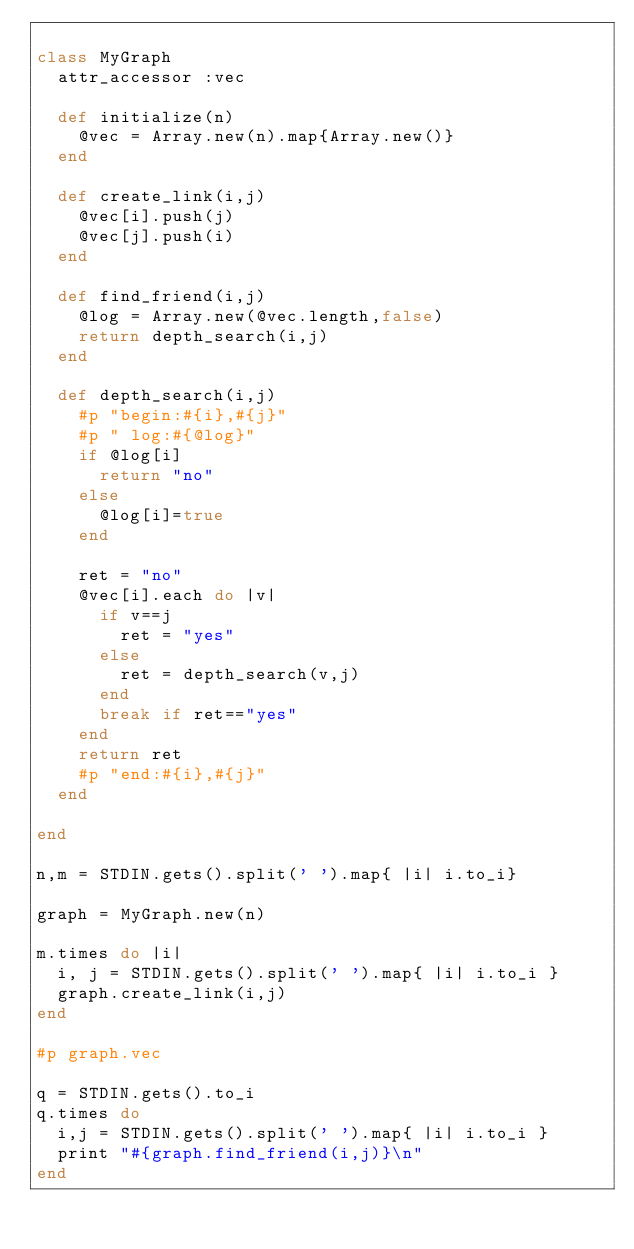<code> <loc_0><loc_0><loc_500><loc_500><_Ruby_>
class MyGraph
  attr_accessor :vec

  def initialize(n)
    @vec = Array.new(n).map{Array.new()}
  end

  def create_link(i,j)
    @vec[i].push(j)
    @vec[j].push(i)
  end

  def find_friend(i,j)
    @log = Array.new(@vec.length,false)
    return depth_search(i,j)
  end

  def depth_search(i,j)
    #p "begin:#{i},#{j}"
    #p " log:#{@log}"
    if @log[i]
      return "no"
    else
      @log[i]=true
    end

    ret = "no"
    @vec[i].each do |v|
      if v==j
        ret = "yes"
      else
        ret = depth_search(v,j)
      end
      break if ret=="yes"
    end
    return ret
    #p "end:#{i},#{j}"
  end

end

n,m = STDIN.gets().split(' ').map{ |i| i.to_i}

graph = MyGraph.new(n)

m.times do |i|
  i, j = STDIN.gets().split(' ').map{ |i| i.to_i }
  graph.create_link(i,j)
end

#p graph.vec

q = STDIN.gets().to_i
q.times do
  i,j = STDIN.gets().split(' ').map{ |i| i.to_i }
  print "#{graph.find_friend(i,j)}\n"
end</code> 